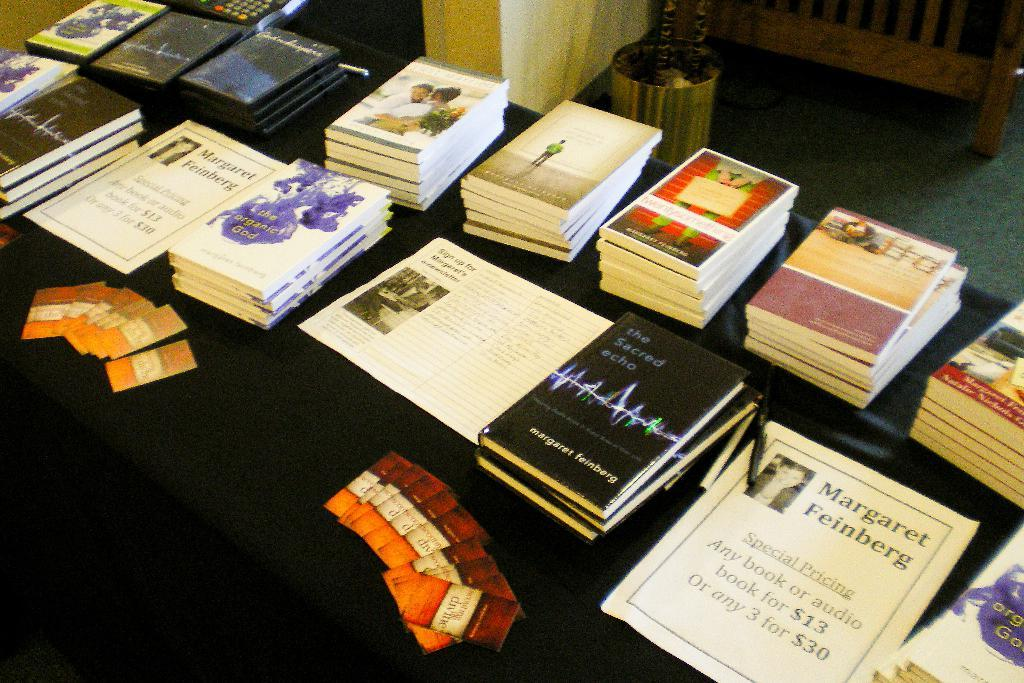<image>
Render a clear and concise summary of the photo. Margaret Feinberg special pricing on any book or audio for thirteen dollars. 